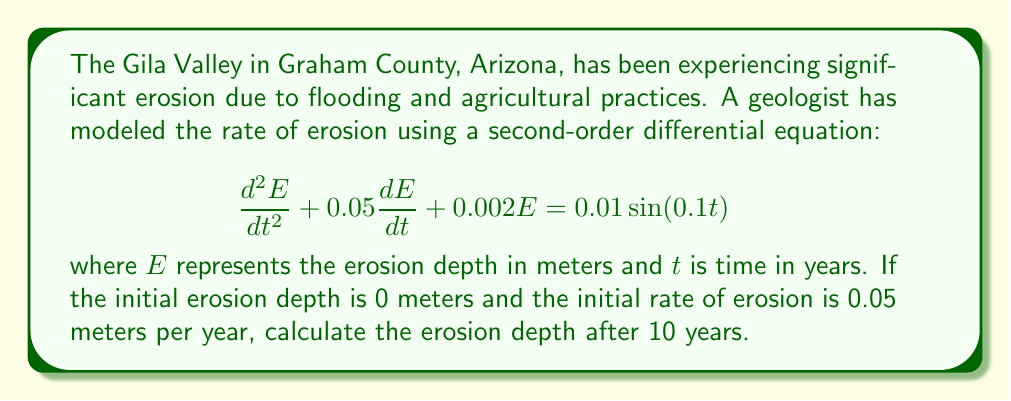Can you solve this math problem? To solve this problem, we need to use the method for solving non-homogeneous second-order linear differential equations.

1) First, let's identify the components of the equation:
   - Homogeneous part: $\frac{d^2E}{dt^2} + 0.05\frac{dE}{dt} + 0.002E = 0$
   - Non-homogeneous part (forcing function): $0.01\sin(0.1t)$

2) We need to find the general solution, which is the sum of the complementary solution (solution to the homogeneous equation) and the particular solution.

3) For the complementary solution, we assume $E = e^{rt}$ and substitute into the homogeneous equation:
   $r^2 + 0.05r + 0.002 = 0$

4) Solving this characteristic equation:
   $r = \frac{-0.05 \pm \sqrt{0.05^2 - 4(1)(0.002)}}{2(1)} \approx -0.0247 \pm 0.0387i$

5) Therefore, the complementary solution is:
   $E_c = c_1e^{-0.0247t}\cos(0.0387t) + c_2e^{-0.0247t}\sin(0.0387t)$

6) For the particular solution, we assume:
   $E_p = A\cos(0.1t) + B\sin(0.1t)$

7) Substituting this into the original equation and solving for A and B:
   $A \approx -0.0988$ and $B \approx 0.0049$

8) The general solution is:
   $E = c_1e^{-0.0247t}\cos(0.0387t) + c_2e^{-0.0247t}\sin(0.0387t) - 0.0988\cos(0.1t) + 0.0049\sin(0.1t)$

9) Using the initial conditions:
   At $t=0$: $E(0) = 0$ and $E'(0) = 0.05$

10) Solving for $c_1$ and $c_2$:
    $c_1 \approx 0.0988$ and $c_2 \approx 0.0641$

11) The final solution is:
    $E = 0.0988e^{-0.0247t}\cos(0.0387t) + 0.0641e^{-0.0247t}\sin(0.0387t) - 0.0988\cos(0.1t) + 0.0049\sin(0.1t)$

12) To find the erosion depth after 10 years, we substitute $t=10$ into this equation.
Answer: The erosion depth after 10 years is approximately 0.0782 meters. 